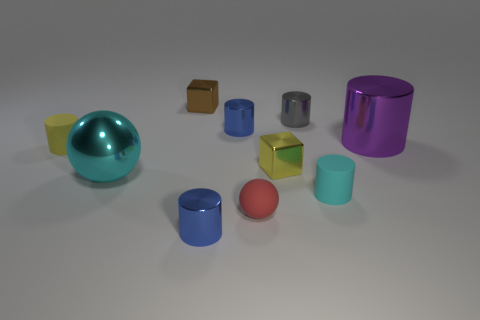Subtract 3 cylinders. How many cylinders are left? 3 Subtract all small cyan rubber cylinders. How many cylinders are left? 5 Subtract all purple cylinders. How many cylinders are left? 5 Subtract all brown cylinders. Subtract all cyan blocks. How many cylinders are left? 6 Subtract all balls. How many objects are left? 8 Subtract all yellow rubber objects. Subtract all yellow matte cylinders. How many objects are left? 8 Add 2 blue things. How many blue things are left? 4 Add 8 blue things. How many blue things exist? 10 Subtract 0 cyan blocks. How many objects are left? 10 